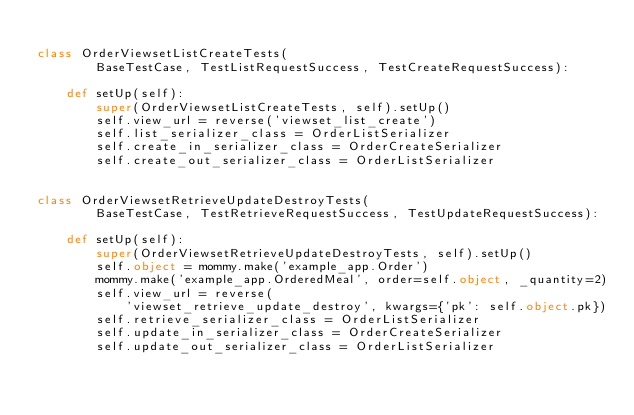<code> <loc_0><loc_0><loc_500><loc_500><_Python_>
class OrderViewsetListCreateTests(
        BaseTestCase, TestListRequestSuccess, TestCreateRequestSuccess):

    def setUp(self):
        super(OrderViewsetListCreateTests, self).setUp()
        self.view_url = reverse('viewset_list_create')
        self.list_serializer_class = OrderListSerializer
        self.create_in_serializer_class = OrderCreateSerializer
        self.create_out_serializer_class = OrderListSerializer


class OrderViewsetRetrieveUpdateDestroyTests(
        BaseTestCase, TestRetrieveRequestSuccess, TestUpdateRequestSuccess):

    def setUp(self):
        super(OrderViewsetRetrieveUpdateDestroyTests, self).setUp()
        self.object = mommy.make('example_app.Order')
        mommy.make('example_app.OrderedMeal', order=self.object, _quantity=2)
        self.view_url = reverse(
            'viewset_retrieve_update_destroy', kwargs={'pk': self.object.pk})
        self.retrieve_serializer_class = OrderListSerializer
        self.update_in_serializer_class = OrderCreateSerializer
        self.update_out_serializer_class = OrderListSerializer
</code> 